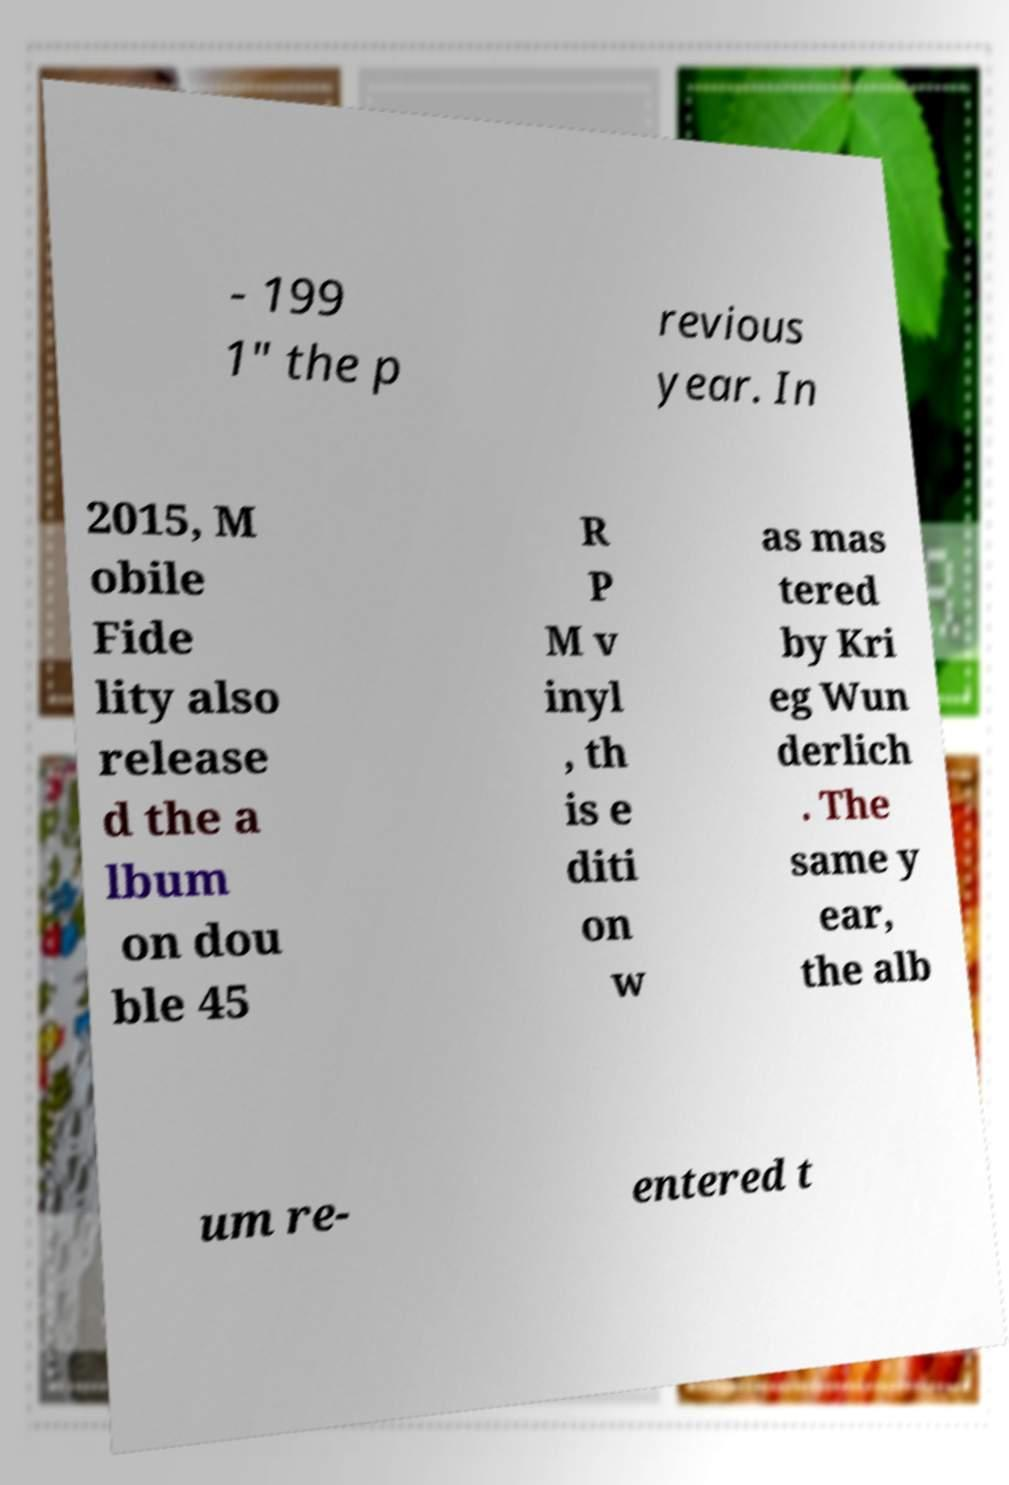I need the written content from this picture converted into text. Can you do that? - 199 1" the p revious year. In 2015, M obile Fide lity also release d the a lbum on dou ble 45 R P M v inyl , th is e diti on w as mas tered by Kri eg Wun derlich . The same y ear, the alb um re- entered t 